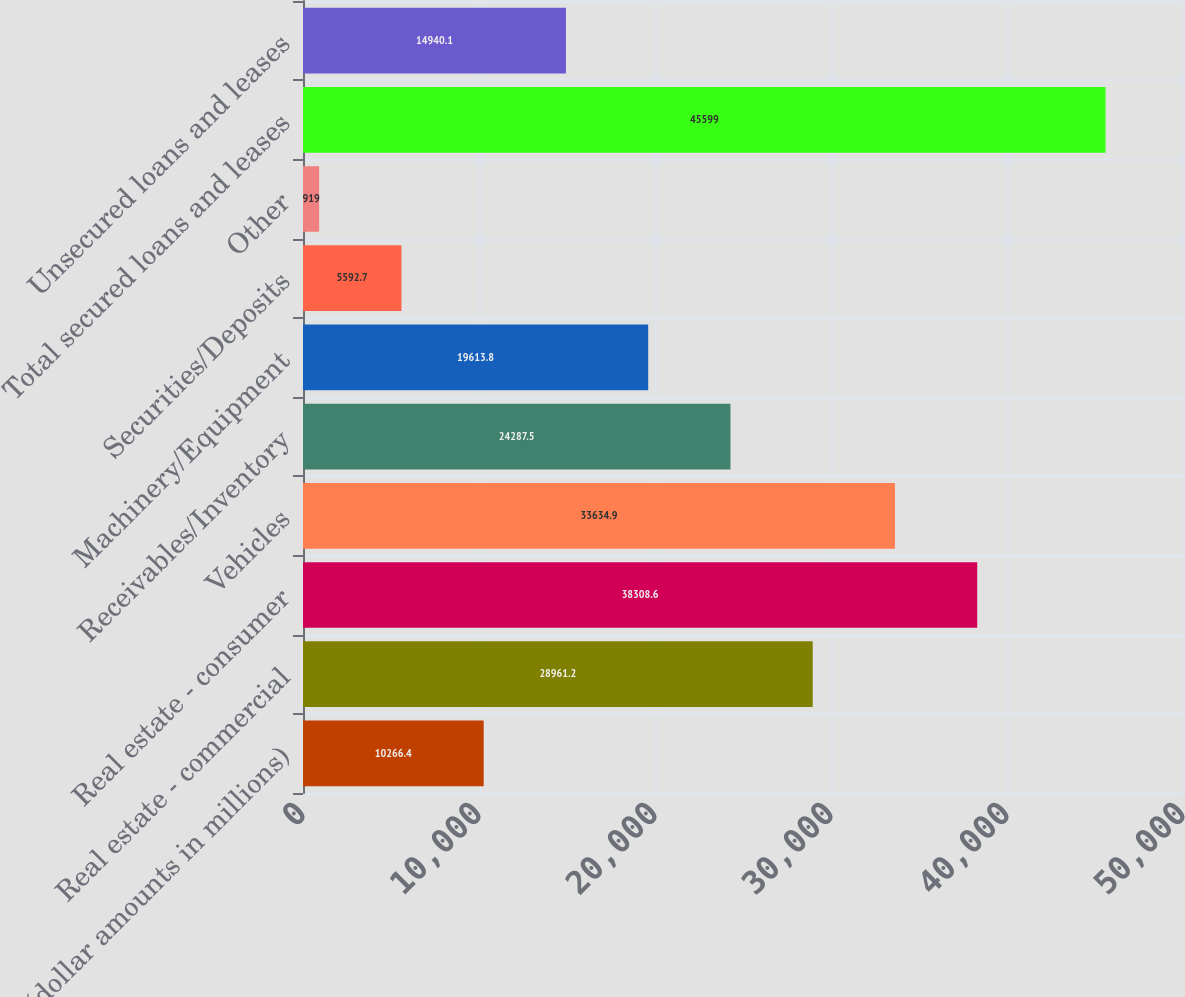Convert chart. <chart><loc_0><loc_0><loc_500><loc_500><bar_chart><fcel>(dollar amounts in millions)<fcel>Real estate - commercial<fcel>Real estate - consumer<fcel>Vehicles<fcel>Receivables/Inventory<fcel>Machinery/Equipment<fcel>Securities/Deposits<fcel>Other<fcel>Total secured loans and leases<fcel>Unsecured loans and leases<nl><fcel>10266.4<fcel>28961.2<fcel>38308.6<fcel>33634.9<fcel>24287.5<fcel>19613.8<fcel>5592.7<fcel>919<fcel>45599<fcel>14940.1<nl></chart> 